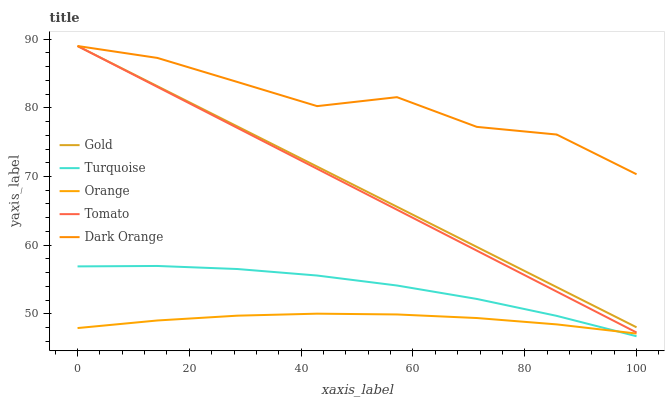Does Orange have the minimum area under the curve?
Answer yes or no. Yes. Does Dark Orange have the maximum area under the curve?
Answer yes or no. Yes. Does Tomato have the minimum area under the curve?
Answer yes or no. No. Does Tomato have the maximum area under the curve?
Answer yes or no. No. Is Tomato the smoothest?
Answer yes or no. Yes. Is Dark Orange the roughest?
Answer yes or no. Yes. Is Turquoise the smoothest?
Answer yes or no. No. Is Turquoise the roughest?
Answer yes or no. No. Does Turquoise have the lowest value?
Answer yes or no. Yes. Does Tomato have the lowest value?
Answer yes or no. No. Does Dark Orange have the highest value?
Answer yes or no. Yes. Does Turquoise have the highest value?
Answer yes or no. No. Is Orange less than Dark Orange?
Answer yes or no. Yes. Is Gold greater than Orange?
Answer yes or no. Yes. Does Dark Orange intersect Tomato?
Answer yes or no. Yes. Is Dark Orange less than Tomato?
Answer yes or no. No. Is Dark Orange greater than Tomato?
Answer yes or no. No. Does Orange intersect Dark Orange?
Answer yes or no. No. 